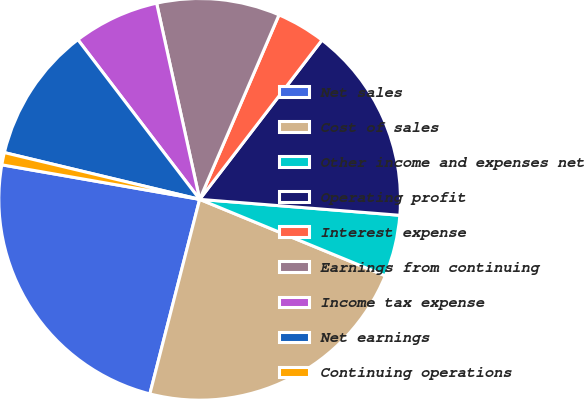Convert chart. <chart><loc_0><loc_0><loc_500><loc_500><pie_chart><fcel>Net sales<fcel>Cost of sales<fcel>Other income and expenses net<fcel>Operating profit<fcel>Interest expense<fcel>Earnings from continuing<fcel>Income tax expense<fcel>Net earnings<fcel>Continuing operations<nl><fcel>23.76%<fcel>22.77%<fcel>4.95%<fcel>15.84%<fcel>3.96%<fcel>9.9%<fcel>6.93%<fcel>10.89%<fcel>0.99%<nl></chart> 